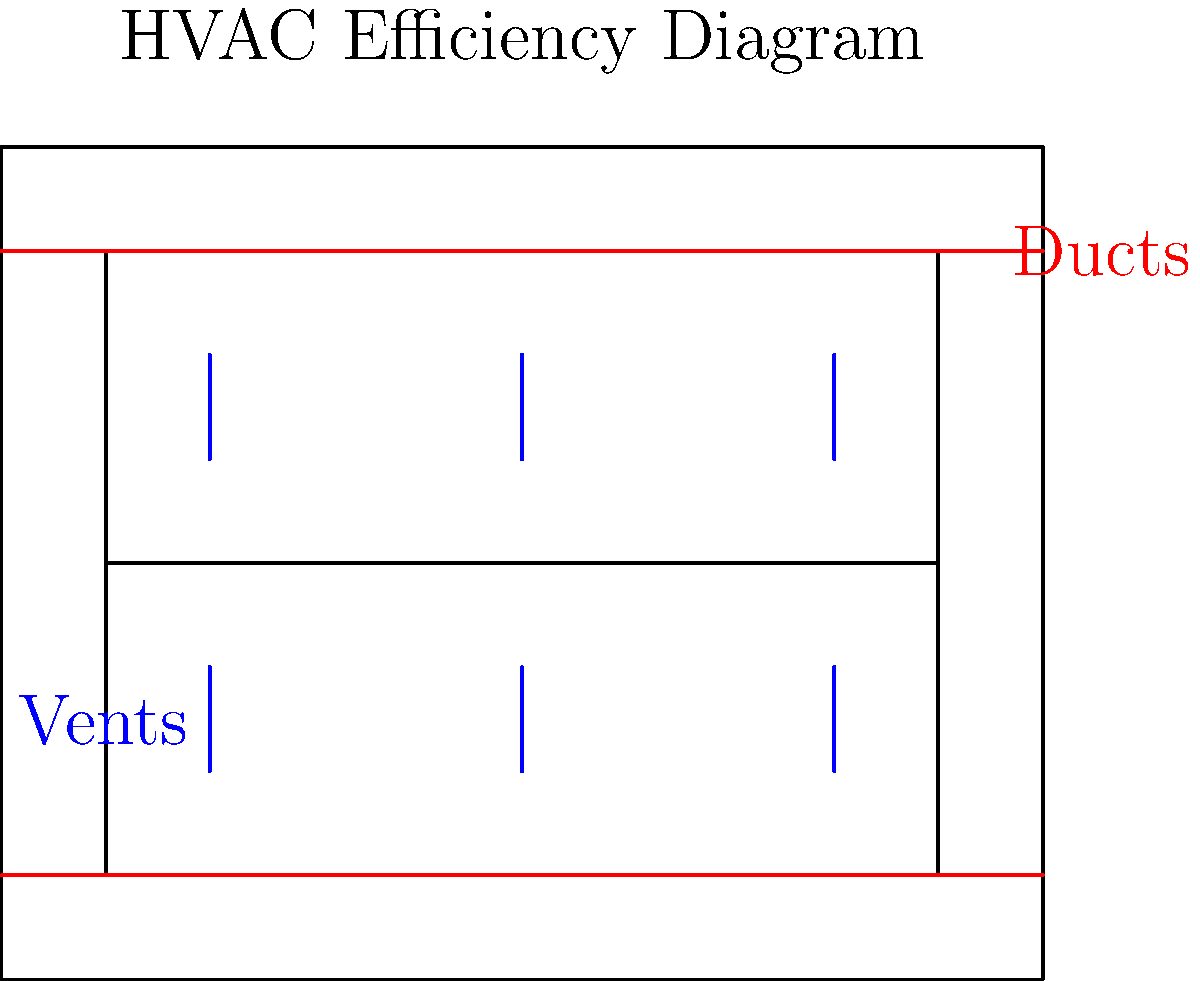In the hospital HVAC system layout shown, there are 6 vents distributed across two floors. If the total airflow capacity of the system is 3000 cubic feet per minute (CFM) and each vent should ideally provide equal airflow, what should be the airflow rate through each vent in CFM? To determine the airflow rate through each vent, we need to follow these steps:

1. Identify the total airflow capacity of the system:
   Total airflow capacity = 3000 CFM

2. Count the number of vents in the system:
   Number of vents = 6

3. Calculate the ideal airflow rate per vent:
   Since we want equal airflow through each vent, we divide the total airflow capacity by the number of vents.

   Airflow rate per vent = Total airflow capacity ÷ Number of vents
   Airflow rate per vent = 3000 CFM ÷ 6
   Airflow rate per vent = 500 CFM

Therefore, for optimal efficiency and equal distribution, each vent should provide an airflow rate of 500 CFM.
Answer: 500 CFM 